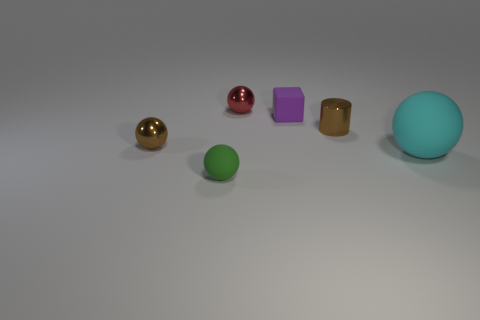Add 2 brown metallic cubes. How many objects exist? 8 Subtract all green balls. How many balls are left? 3 Subtract all tiny balls. How many balls are left? 1 Subtract 0 brown blocks. How many objects are left? 6 Subtract all blocks. How many objects are left? 5 Subtract 1 spheres. How many spheres are left? 3 Subtract all blue cylinders. Subtract all gray cubes. How many cylinders are left? 1 Subtract all purple spheres. How many gray cylinders are left? 0 Subtract all small blue metallic cubes. Subtract all large cyan rubber objects. How many objects are left? 5 Add 5 cylinders. How many cylinders are left? 6 